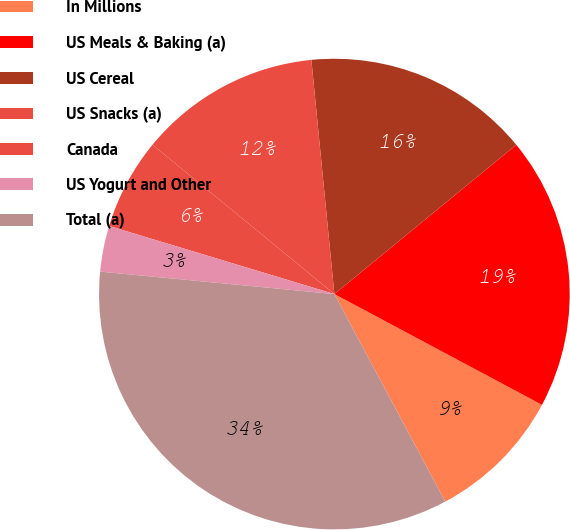Convert chart. <chart><loc_0><loc_0><loc_500><loc_500><pie_chart><fcel>In Millions<fcel>US Meals & Baking (a)<fcel>US Cereal<fcel>US Snacks (a)<fcel>Canada<fcel>US Yogurt and Other<fcel>Total (a)<nl><fcel>9.39%<fcel>18.74%<fcel>15.62%<fcel>12.5%<fcel>6.27%<fcel>3.15%<fcel>34.33%<nl></chart> 